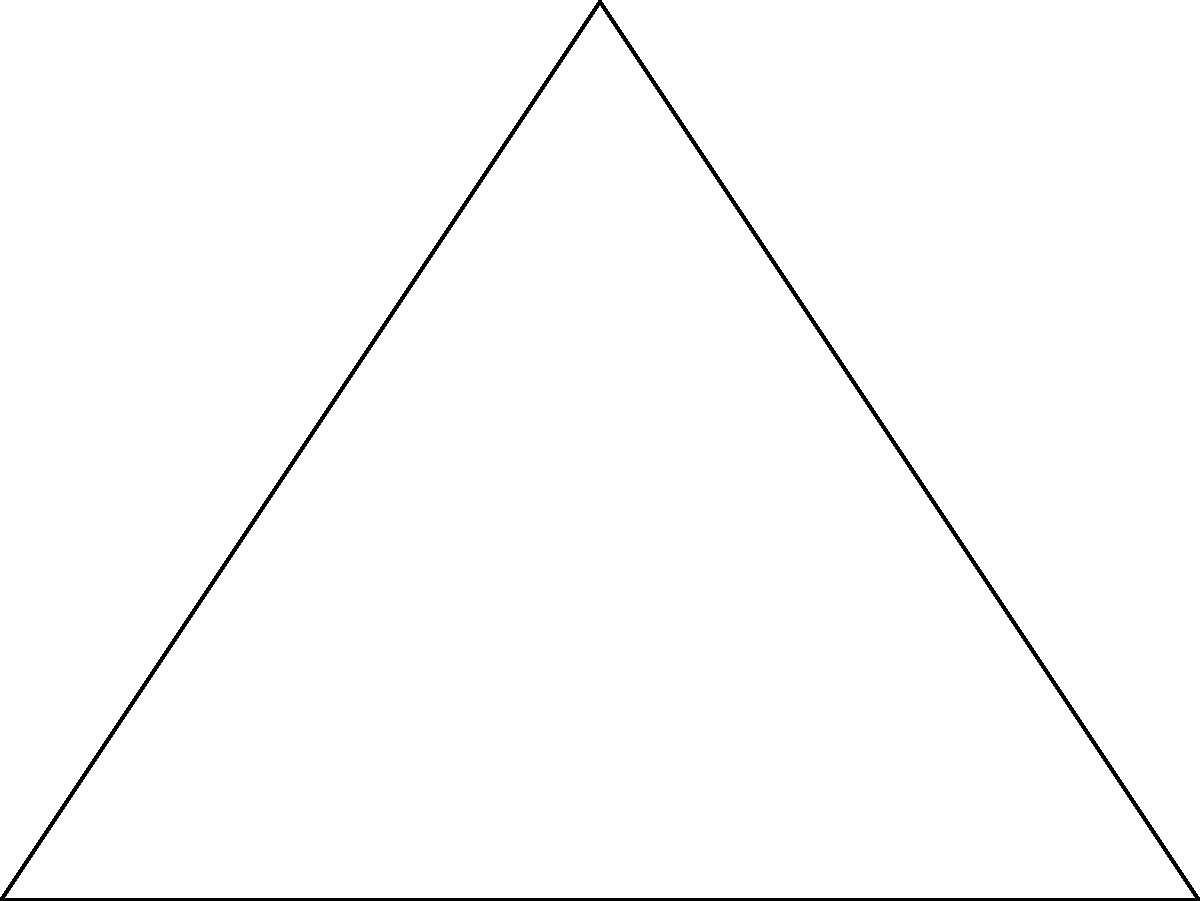In a home theater setup, three surround sound speakers are positioned at the vertices of a triangle ABC, with the screen along side AB. The center speaker O is placed 2 meters from each side of the triangle. If AB = 8 meters and the area of triangle ABC is 24 square meters, what is the distance between the center speaker O and the rear speaker at point C? Let's approach this step-by-step:

1) First, we need to find the height of the triangle. We can do this using the area formula:
   Area = $\frac{1}{2}$ * base * height
   $24 = \frac{1}{2} * 8 * h$
   $h = 6$ meters

2) Now we know the coordinates of the triangle:
   A(0,0), B(8,0), C(4,6)

3) The center speaker O is equidistant from all sides of the triangle. This means it's at the intersection of the angle bisectors, which is also the center of the inscribed circle.

4) The coordinates of O can be calculated as:
   $O_x = \frac{a*x_a + b*x_b + c*x_c}{a+b+c}$
   $O_y = \frac{a*y_a + b*y_b + c*y_c}{a+b+c}$
   Where a, b, c are the side lengths of the triangle.

5) We can calculate these side lengths:
   $AB = 8$
   $AC = \sqrt{4^2 + 6^2} = \sqrt{52} = 7.21$
   $BC = \sqrt{4^2 + 6^2} = \sqrt{52} = 7.21$

6) Plugging into the formulas:
   $O_x = \frac{7.21*0 + 7.21*8 + 8*4}{7.21+7.21+8} = 4$
   $O_y = \frac{7.21*0 + 7.21*0 + 8*6}{7.21+7.21+8} = 2$

7) So O is at (4,2)

8) Now we can calculate the distance OC:
   $OC = \sqrt{(4-4)^2 + (6-2)^2} = \sqrt{16} = 4$ meters

Therefore, the distance between the center speaker O and the rear speaker at point C is 4 meters.
Answer: 4 meters 